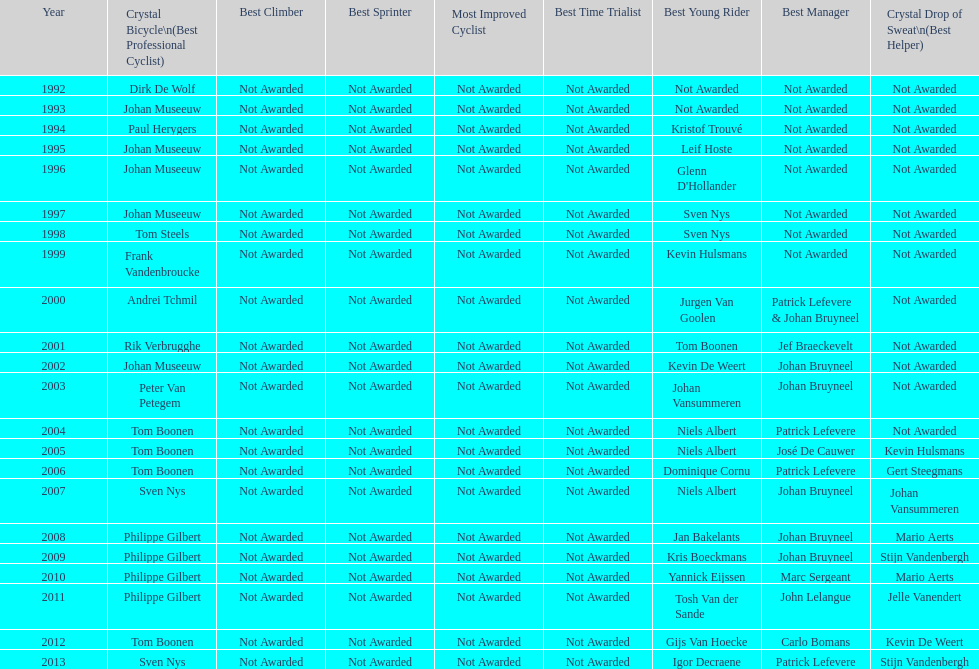Who won the most consecutive crystal bicycles? Philippe Gilbert. 